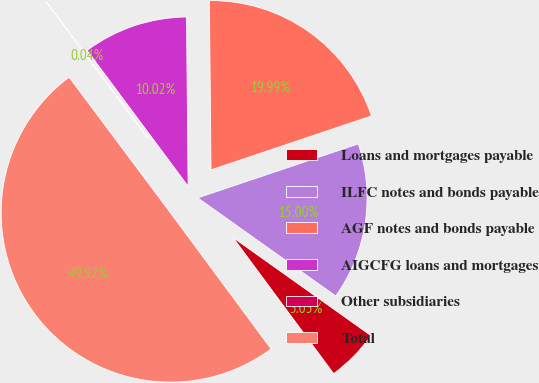Convert chart to OTSL. <chart><loc_0><loc_0><loc_500><loc_500><pie_chart><fcel>Loans and mortgages payable<fcel>ILFC notes and bonds payable<fcel>AGF notes and bonds payable<fcel>AIGCFG loans and mortgages<fcel>Other subsidiaries<fcel>Total<nl><fcel>5.03%<fcel>15.0%<fcel>19.99%<fcel>10.02%<fcel>0.04%<fcel>49.92%<nl></chart> 